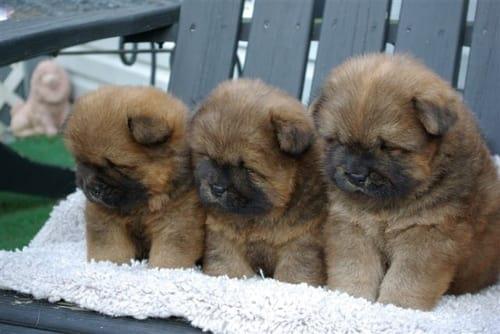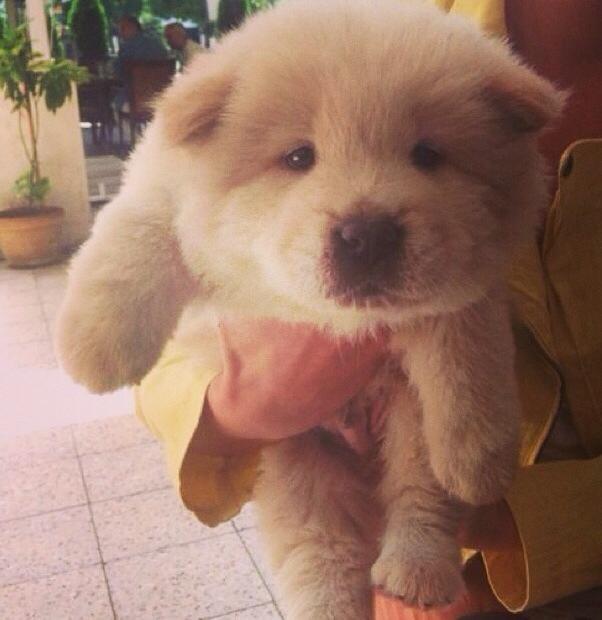The first image is the image on the left, the second image is the image on the right. Assess this claim about the two images: "In one image, a small white dog is beside driftwood and in front of a wooden wall.". Correct or not? Answer yes or no. No. The first image is the image on the left, the second image is the image on the right. Analyze the images presented: Is the assertion "An image shows three chow pups on a plush surface." valid? Answer yes or no. Yes. 